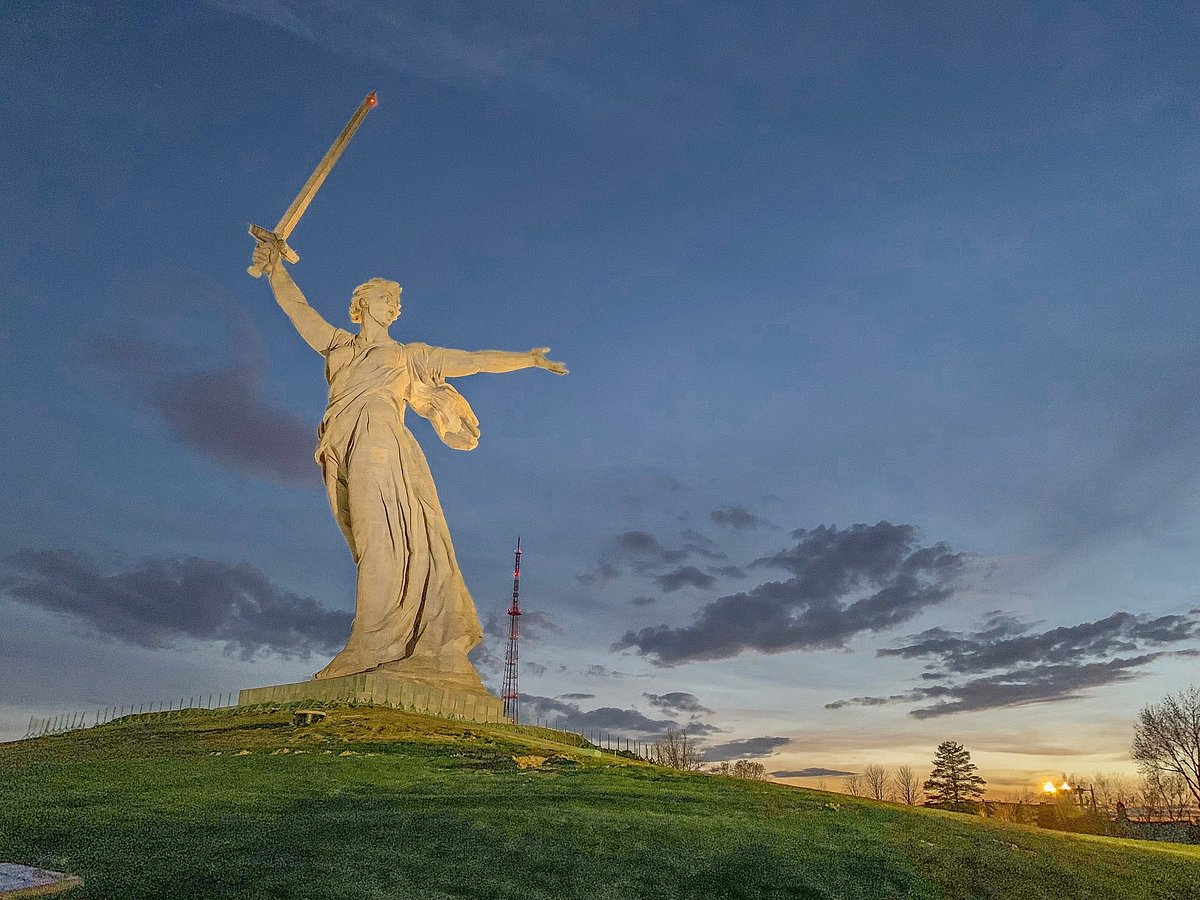If a mystical creature were to come alive from this scene, what would it be and why? In this scene, the mystical creature that would come alive is a Guardian Griffin. Emerging from the shadows at twilight, this majestic beast, with the body of a lion and the wings and head of an eagle, represents the melding of strength and vigilance. The Griffin surveys the land with keen eyes, ready to protect and guide the spirits of those who fought bravely. Its presence evokes a sense of ancient power and wisdom, embodying the resilience and pride symbolized by the statue itself. 